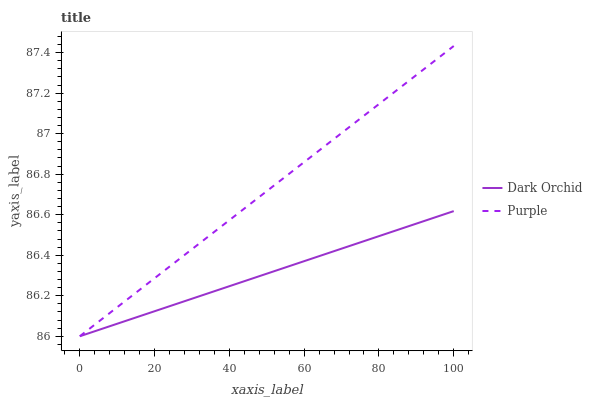Does Dark Orchid have the maximum area under the curve?
Answer yes or no. No. Is Dark Orchid the roughest?
Answer yes or no. No. Does Dark Orchid have the highest value?
Answer yes or no. No. 